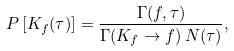<formula> <loc_0><loc_0><loc_500><loc_500>P \left [ K _ { f } ( \tau ) \right ] = \frac { \Gamma ( f , \tau ) } { \Gamma ( K _ { f } \to f ) \, N ( \tau ) } ,</formula> 